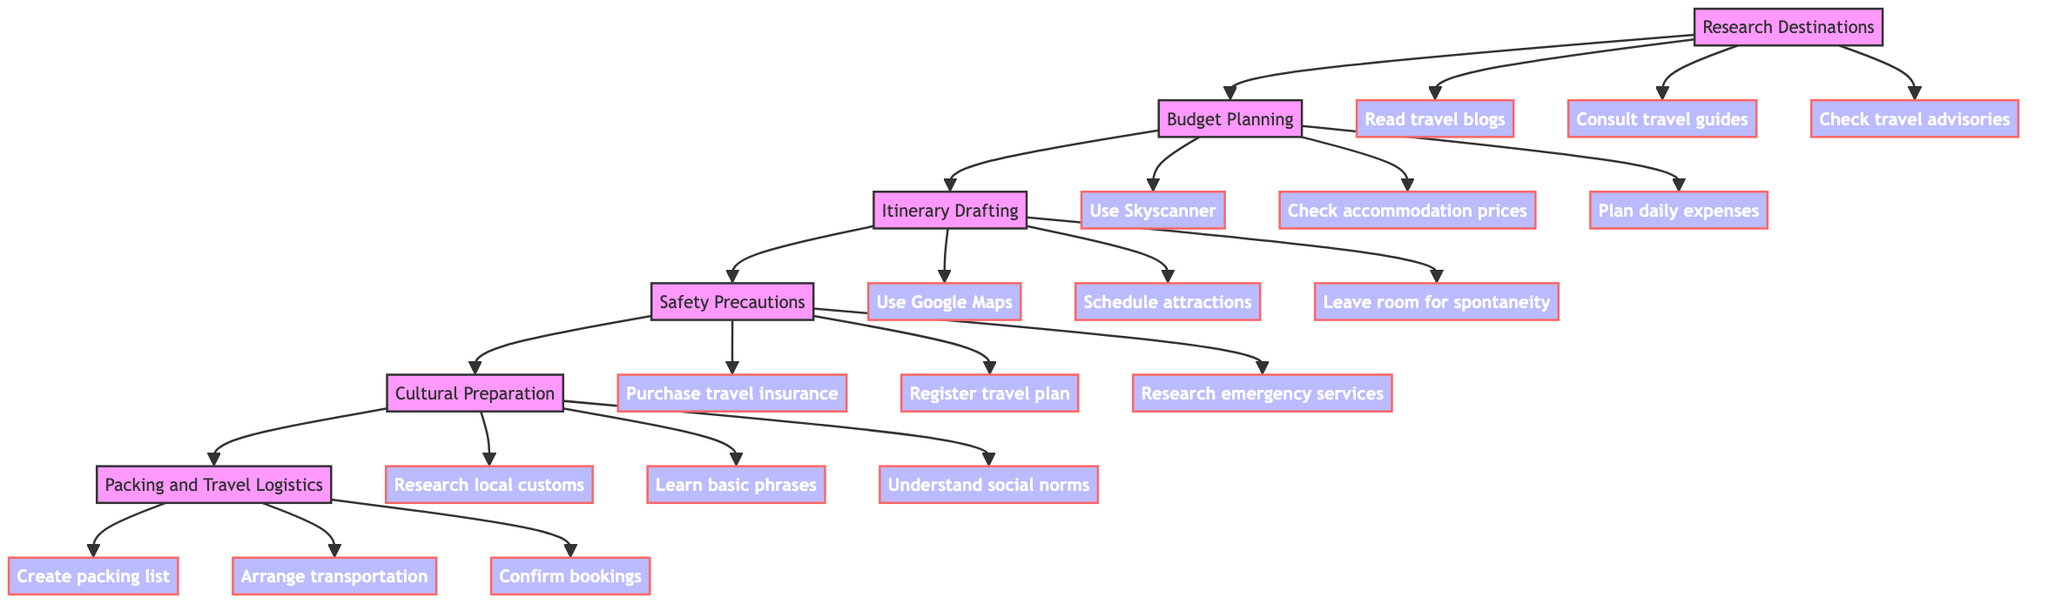What is the first step in the travel planning process? The first step is labeled as "Research Destinations," which is the initial point in the flow chart.
Answer: Research Destinations How many major steps are involved in the itinerary planning process? The flowchart includes six major steps from "Research Destinations" to "Packing and Travel Logistics."
Answer: Six What is the action associated with "Itinerary Drafting"? The action listed under "Itinerary Drafting" includes using Google Maps to plan routes and distances.
Answer: Use Google Maps Which step comes immediately after "Safety Precautions"? Following "Safety Precautions," the next step in the flowchart is "Cultural Preparation."
Answer: Cultural Preparation What action does "Budget Planning" suggest for accommodation pricing? Under "Budget Planning," the action specified is to check accommodation prices on sites like Booking.com or Airbnb.
Answer: Check accommodation prices What is the last action you need to perform in the flowchart? The final action in the process is to confirm your bookings, ensuring you have accurate transportation and accommodations.
Answer: Confirm bookings Which step emphasizes learning about local traditions? The step "Cultural Preparation" specifically emphasizes the importance of understanding local customs and traditions for respectful interactions.
Answer: Cultural Preparation What two actions are included under "Packing and Travel Logistics"? In this step, the actions involve creating a packing list and arranging transportation to the airport or train station.
Answer: Create packing list and arrange transportation Which action in "Safety Precautions" involves health facilities? The action that mentions health facilities is researching local emergency numbers and health facilities, which ensures you are prepared for medical assistance.
Answer: Research emergency services 